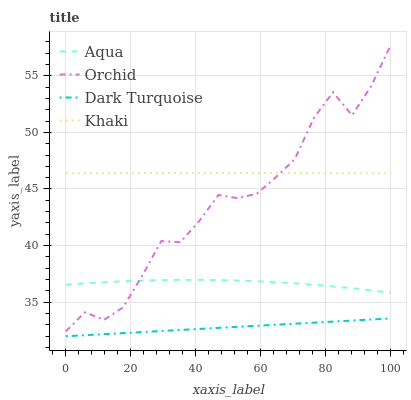Does Aqua have the minimum area under the curve?
Answer yes or no. No. Does Aqua have the maximum area under the curve?
Answer yes or no. No. Is Khaki the smoothest?
Answer yes or no. No. Is Khaki the roughest?
Answer yes or no. No. Does Aqua have the lowest value?
Answer yes or no. No. Does Khaki have the highest value?
Answer yes or no. No. Is Dark Turquoise less than Khaki?
Answer yes or no. Yes. Is Aqua greater than Dark Turquoise?
Answer yes or no. Yes. Does Dark Turquoise intersect Khaki?
Answer yes or no. No. 